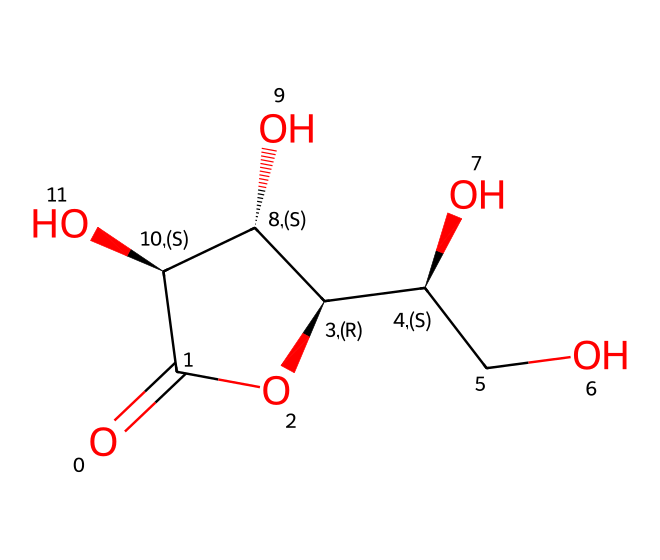What is the name of this vitamin? The chemical structure corresponds to ascorbic acid, commonly known as vitamin C. This can be identified based on the arrangement of carbon atoms, hydroxyl groups, and the carbonyl group present in the structure.
Answer: vitamin C How many carbon atoms are in the structure? By analyzing the SMILES representation, we can count the carbon atoms present in the cyclic structure. There are six carbon atoms visible in the entire molecule.
Answer: six What functional groups are present in vitamin C? The structure of vitamin C includes multiple functional groups such as hydroxyl (-OH) groups and a carbonyl (C=O) group. The presence of these functional groups can be identified by their specific arrangements in the SMILES representation.
Answer: hydroxyl and carbonyl Which part of the structure contributes to its antioxidant properties? The specific arrangement of hydroxyl groups (OH) contributes significantly to the antioxidant properties of vitamin C. These groups can donate hydrogen atoms, helping to neutralize free radicals.
Answer: hydroxyl groups What is the molecular formula of vitamin C? To derive the molecular formula from the SMILES, count the number of each type of atom. The structure shows 6 carbons, 8 hydrogens, and 6 oxygens, which gives the formula C6H8O6.
Answer: C6H8O6 How many total oxygen atoms are present? From the SMILES representation of the structure, we can identify a total of six oxygen atoms in the molecule, including those in hydroxyl and carbonyl groups.
Answer: six 